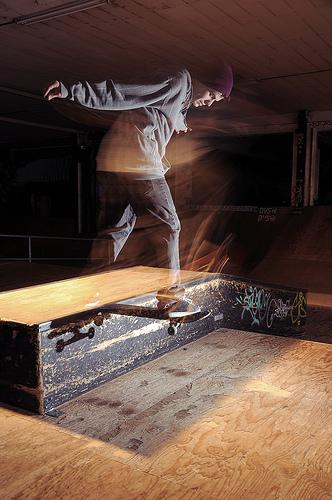Question: why is the picture blurry?
Choices:
A. It was raining.
B. The camera is broken.
C. The object moved.
D. Movement.
Answer with the letter. Answer: D Question: what is the teenager doing?
Choices:
A. Skateboarding.
B. Smoking.
C. Running.
D. Reading.
Answer with the letter. Answer: A Question: how many teenagers are there?
Choices:
A. Thirty-two.
B. Seventeen.
C. One.
D. Four.
Answer with the letter. Answer: C Question: what is the floor made of?
Choices:
A. Concrete.
B. Cement.
C. Wood.
D. Steel.
Answer with the letter. Answer: C 